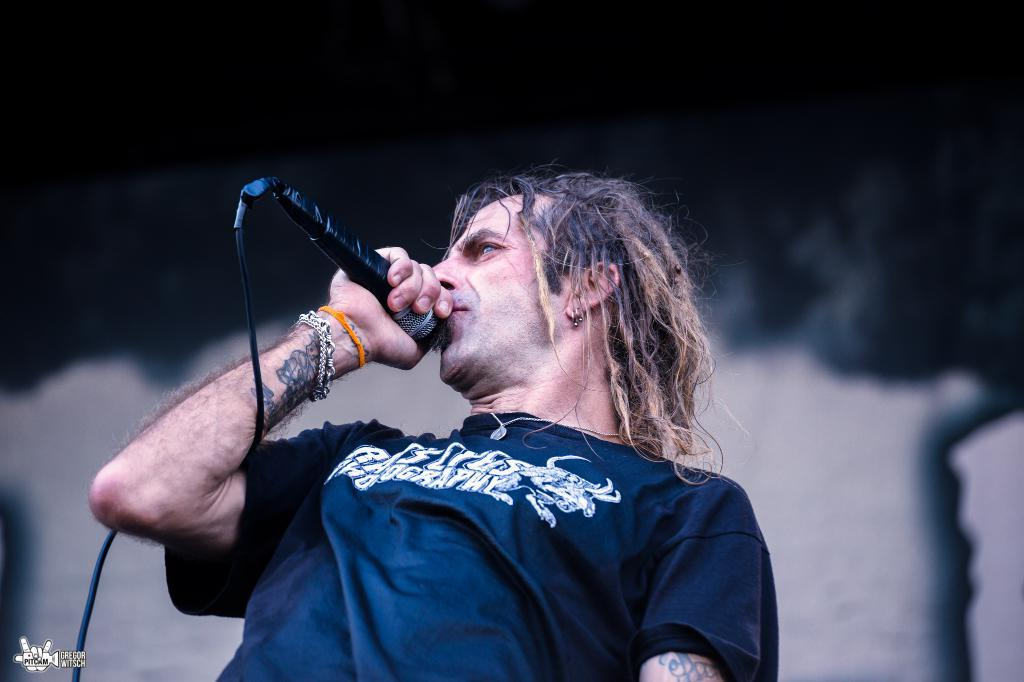Who is in the image? There is a person in the image, specifically a man. What is the man holding in the image? The man is holding a microphone. What is the man doing with the microphone? The man is speaking into the microphone. What type of skirt is the man wearing in the image? There is no skirt present in the image, as the man is wearing clothing appropriate for holding and speaking into a microphone. 